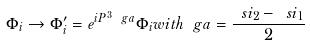Convert formula to latex. <formula><loc_0><loc_0><loc_500><loc_500>\Phi _ { i } \rightarrow \Phi ^ { \prime } _ { i } = e ^ { i P ^ { 3 } \ g a } \Phi _ { i } w i t h \ g a = \frac { \ s i _ { 2 } - \ s i _ { 1 } } { 2 }</formula> 